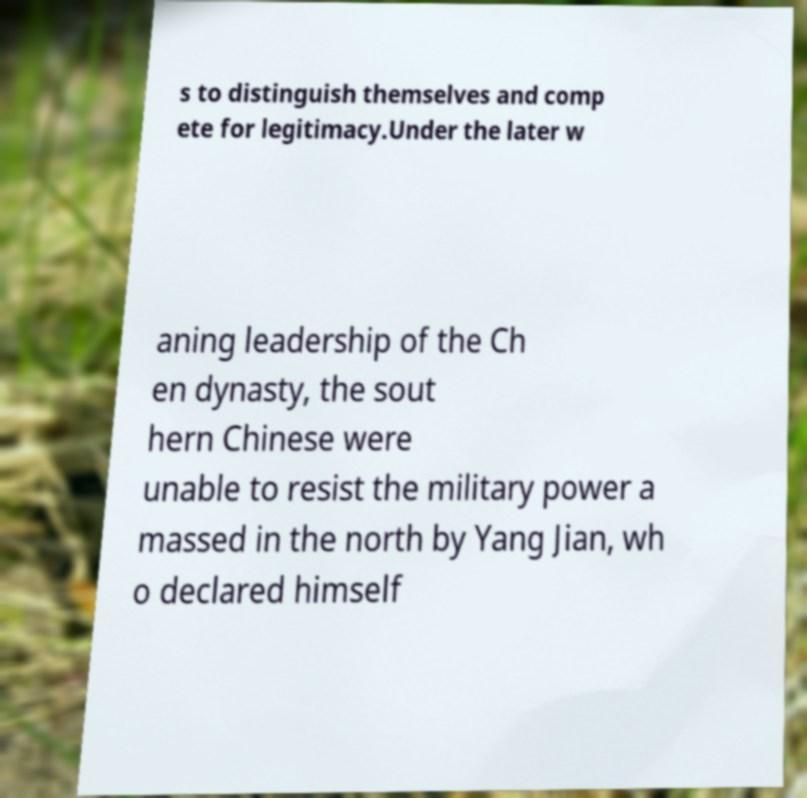Could you assist in decoding the text presented in this image and type it out clearly? s to distinguish themselves and comp ete for legitimacy.Under the later w aning leadership of the Ch en dynasty, the sout hern Chinese were unable to resist the military power a massed in the north by Yang Jian, wh o declared himself 